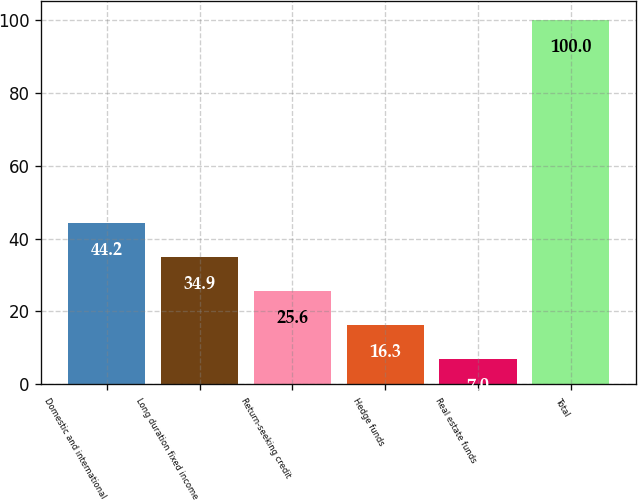<chart> <loc_0><loc_0><loc_500><loc_500><bar_chart><fcel>Domestic and international<fcel>Long duration fixed income<fcel>Return-seeking credit<fcel>Hedge funds<fcel>Real estate funds<fcel>Total<nl><fcel>44.2<fcel>34.9<fcel>25.6<fcel>16.3<fcel>7<fcel>100<nl></chart> 